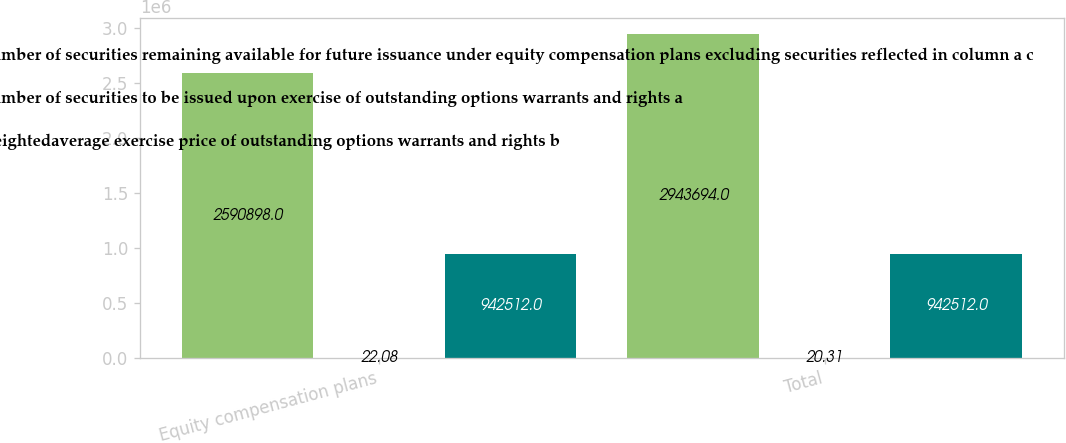Convert chart. <chart><loc_0><loc_0><loc_500><loc_500><stacked_bar_chart><ecel><fcel>Equity compensation plans<fcel>Total<nl><fcel>Number of securities remaining available for future issuance under equity compensation plans excluding securities reflected in column a c<fcel>2.5909e+06<fcel>2.94369e+06<nl><fcel>Number of securities to be issued upon exercise of outstanding options warrants and rights a<fcel>22.08<fcel>20.31<nl><fcel>Weightedaverage exercise price of outstanding options warrants and rights b<fcel>942512<fcel>942512<nl></chart> 